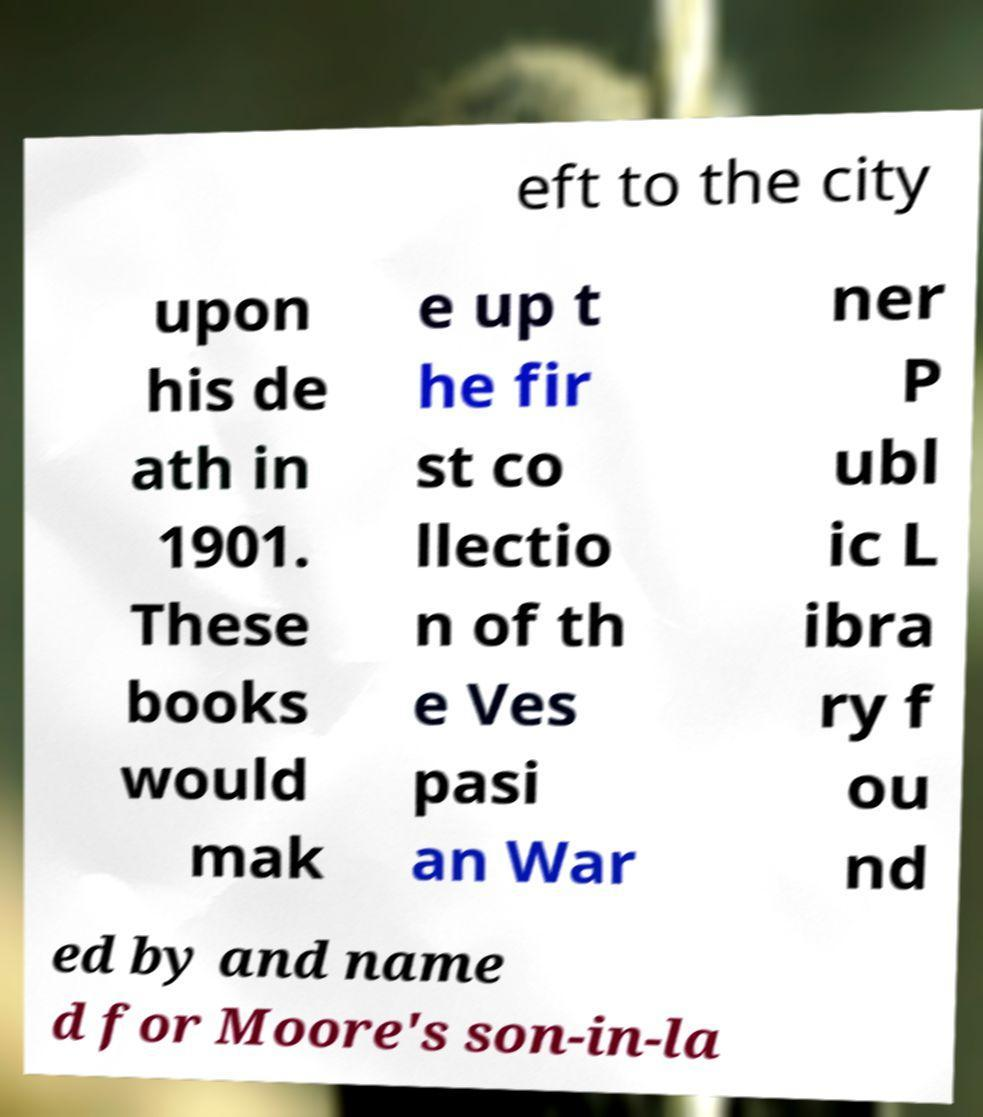What messages or text are displayed in this image? I need them in a readable, typed format. eft to the city upon his de ath in 1901. These books would mak e up t he fir st co llectio n of th e Ves pasi an War ner P ubl ic L ibra ry f ou nd ed by and name d for Moore's son-in-la 